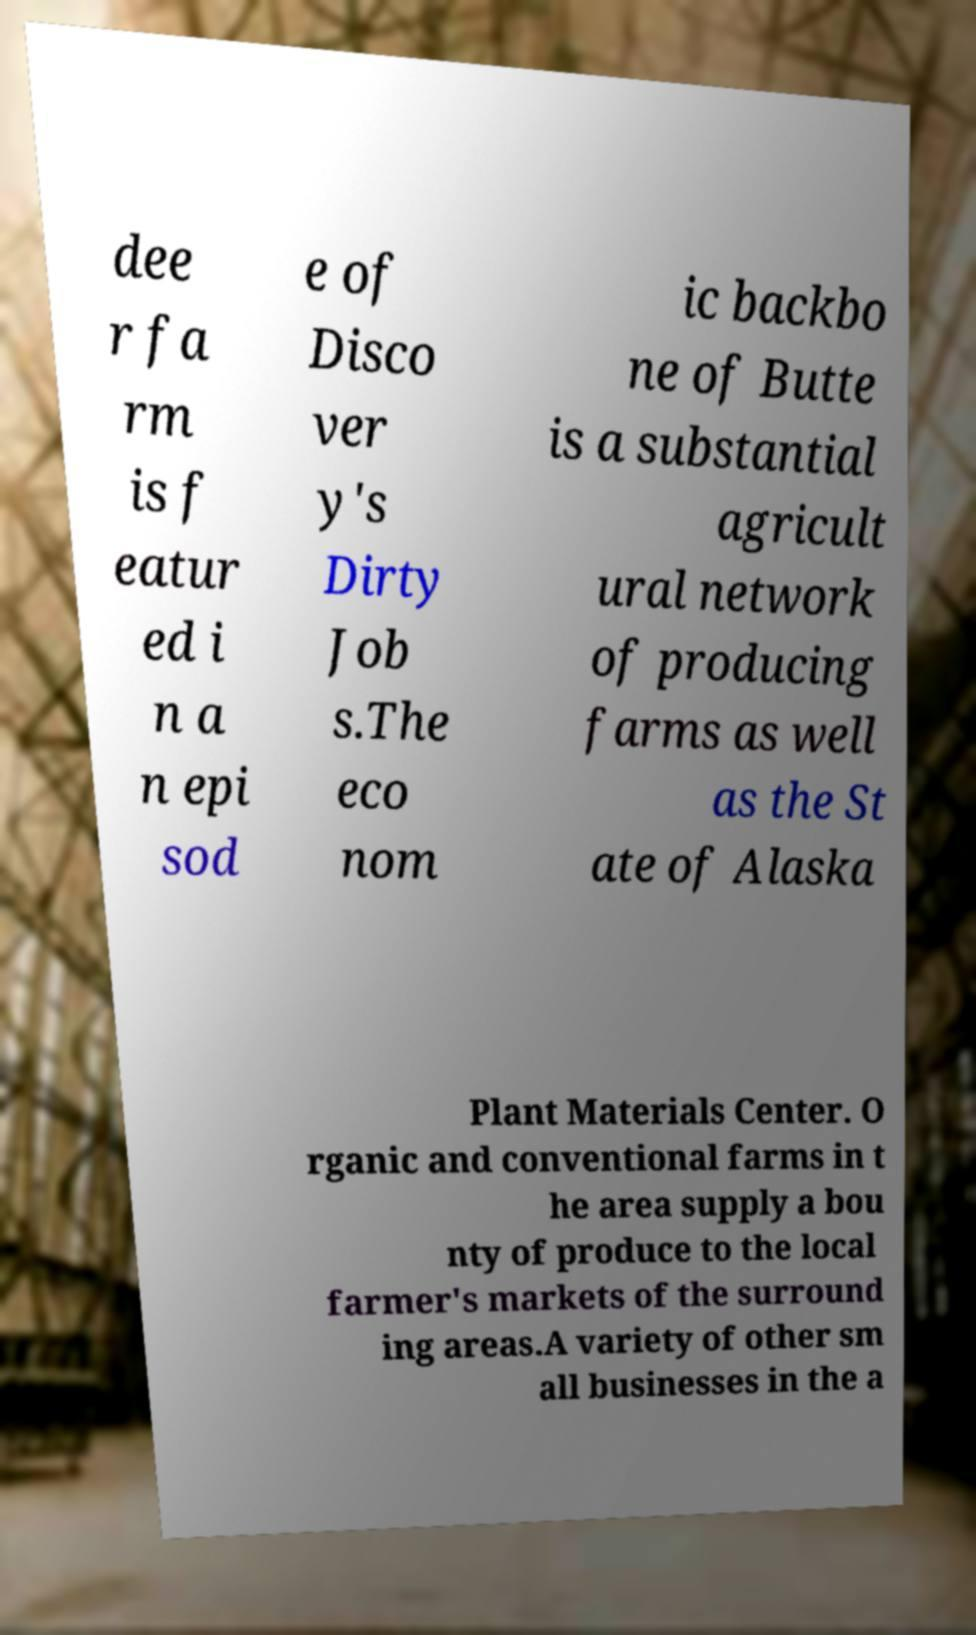There's text embedded in this image that I need extracted. Can you transcribe it verbatim? dee r fa rm is f eatur ed i n a n epi sod e of Disco ver y's Dirty Job s.The eco nom ic backbo ne of Butte is a substantial agricult ural network of producing farms as well as the St ate of Alaska Plant Materials Center. O rganic and conventional farms in t he area supply a bou nty of produce to the local farmer's markets of the surround ing areas.A variety of other sm all businesses in the a 